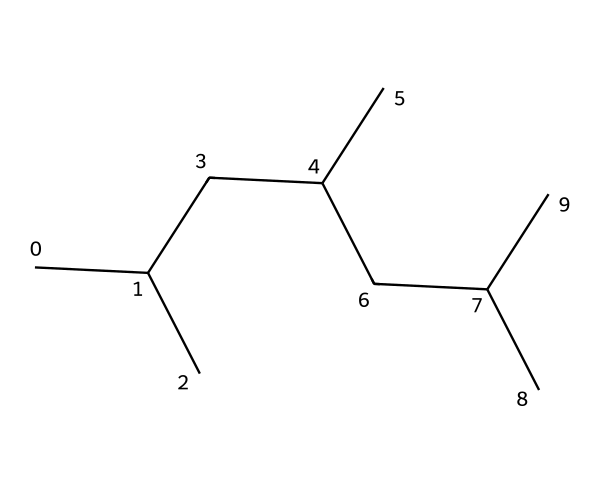What is the molecular formula for this compound? To derive the molecular formula, we count the number of carbon (C) and hydrogen (H) atoms in the structure. The provided SMILES indicates that the structure consists of 15 carbons and 30 hydrogens, resulting in the formula C15H30.
Answer: C15H30 How many carbon atoms are in this polypropylene structure? By analyzing the SMILES representation, we identify each 'C' corresponds to a carbon atom, revealing that there are 15 carbon atoms in total.
Answer: 15 What type of polymer is represented by this structure? The given molecular structure indicates that the compound is polypropylene, which is a type of thermoplastic polymer. The presence of a chain of carbon atoms with hydrogen indicates its polymeric nature.
Answer: polypropylene What is the degree of saturation of this molecule? The degree of saturation can be determined by counting the number of double or triple bonds present, but since this SMILES indicates only single bonds in a linear fashion, the degree of saturation is highest, indicating it's a fully saturated polymer.
Answer: saturated Is this molecule likely to be crystalline or amorphous in nature? Polypropylene tends to have a high degree of crystallinity due to its regular structure from repeated units of the same carbon chain, allowing it to pack efficiently in a solid state.
Answer: crystalline 